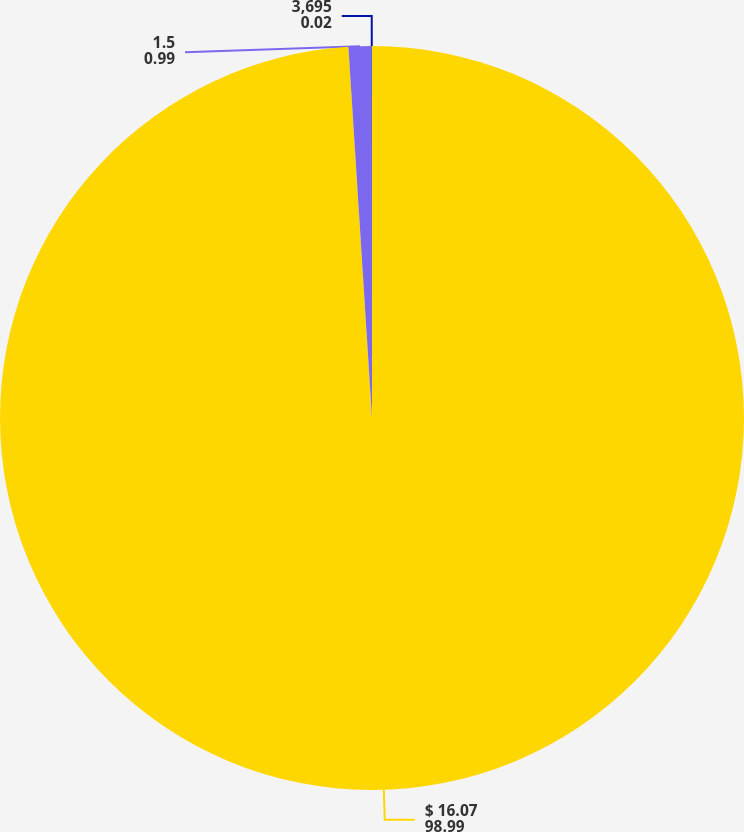<chart> <loc_0><loc_0><loc_500><loc_500><pie_chart><fcel>$ 16.07<fcel>1.5<fcel>3,695<nl><fcel>98.99%<fcel>0.99%<fcel>0.02%<nl></chart> 